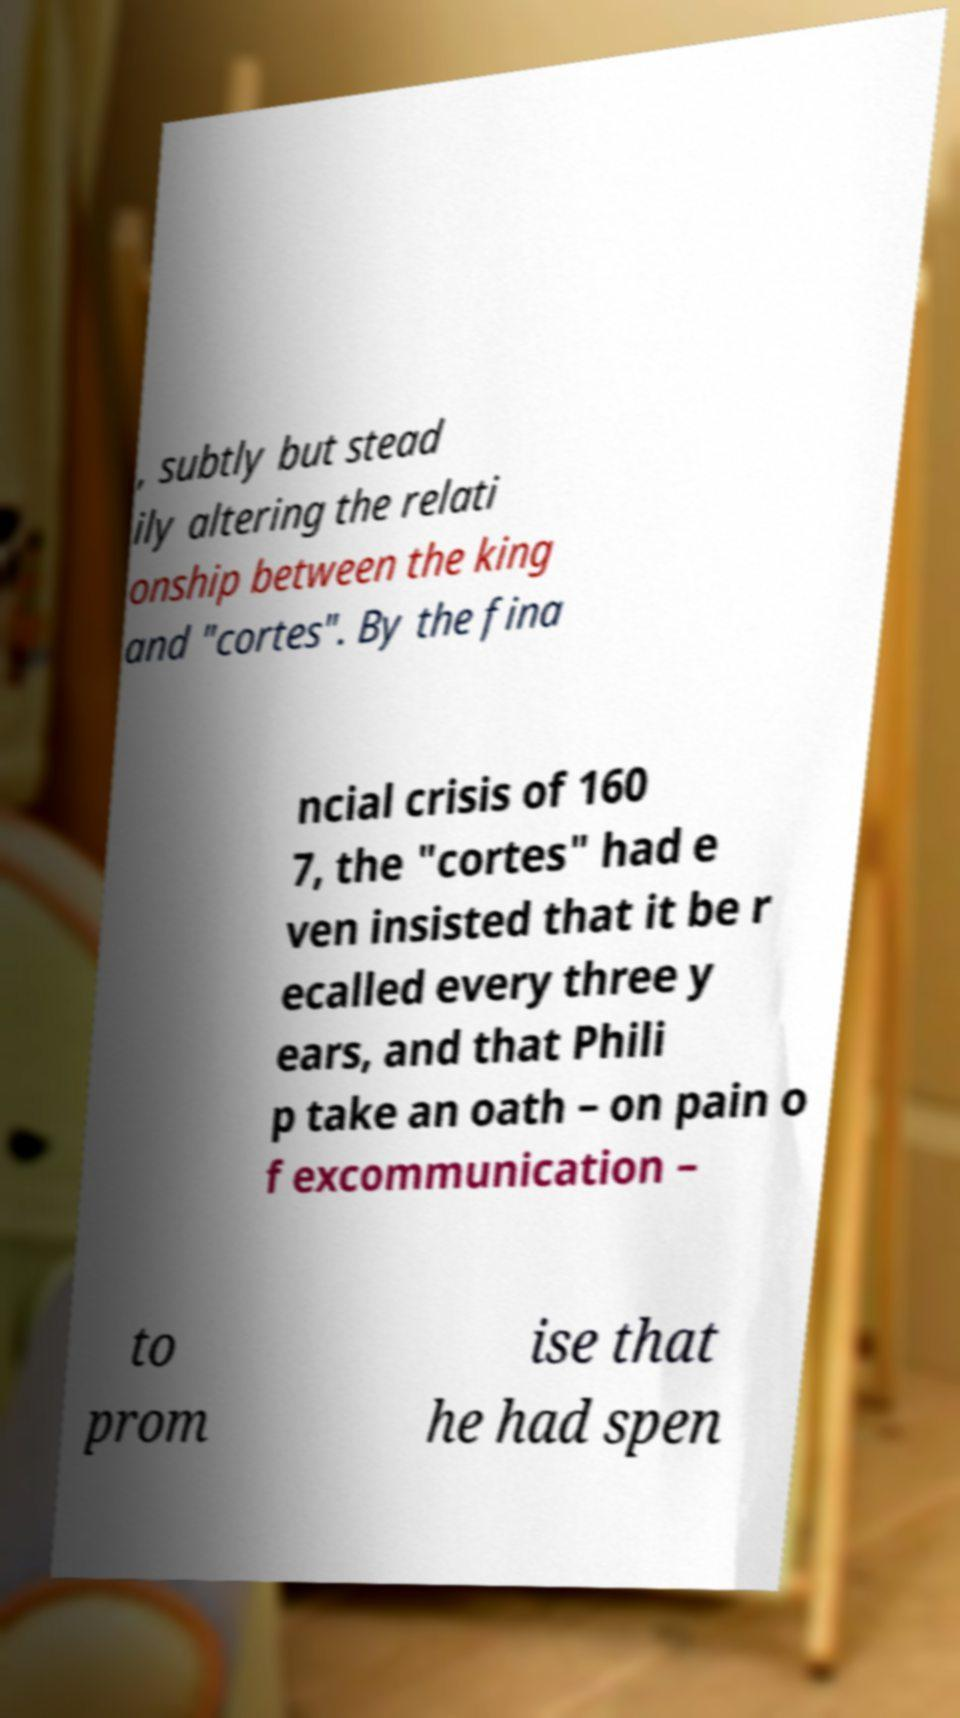Please read and relay the text visible in this image. What does it say? , subtly but stead ily altering the relati onship between the king and "cortes". By the fina ncial crisis of 160 7, the "cortes" had e ven insisted that it be r ecalled every three y ears, and that Phili p take an oath – on pain o f excommunication – to prom ise that he had spen 